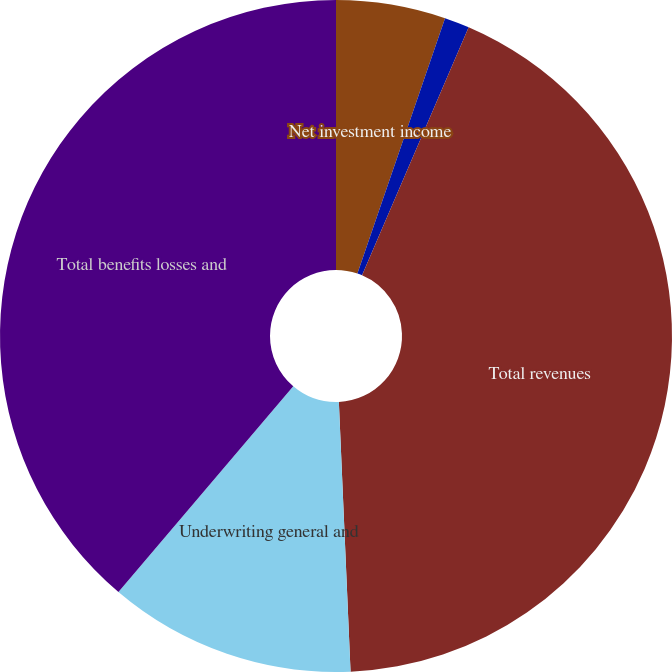Convert chart to OTSL. <chart><loc_0><loc_0><loc_500><loc_500><pie_chart><fcel>Net investment income<fcel>Fees and other income<fcel>Total revenues<fcel>Underwriting general and<fcel>Total benefits losses and<nl><fcel>5.26%<fcel>1.2%<fcel>42.85%<fcel>11.9%<fcel>38.79%<nl></chart> 